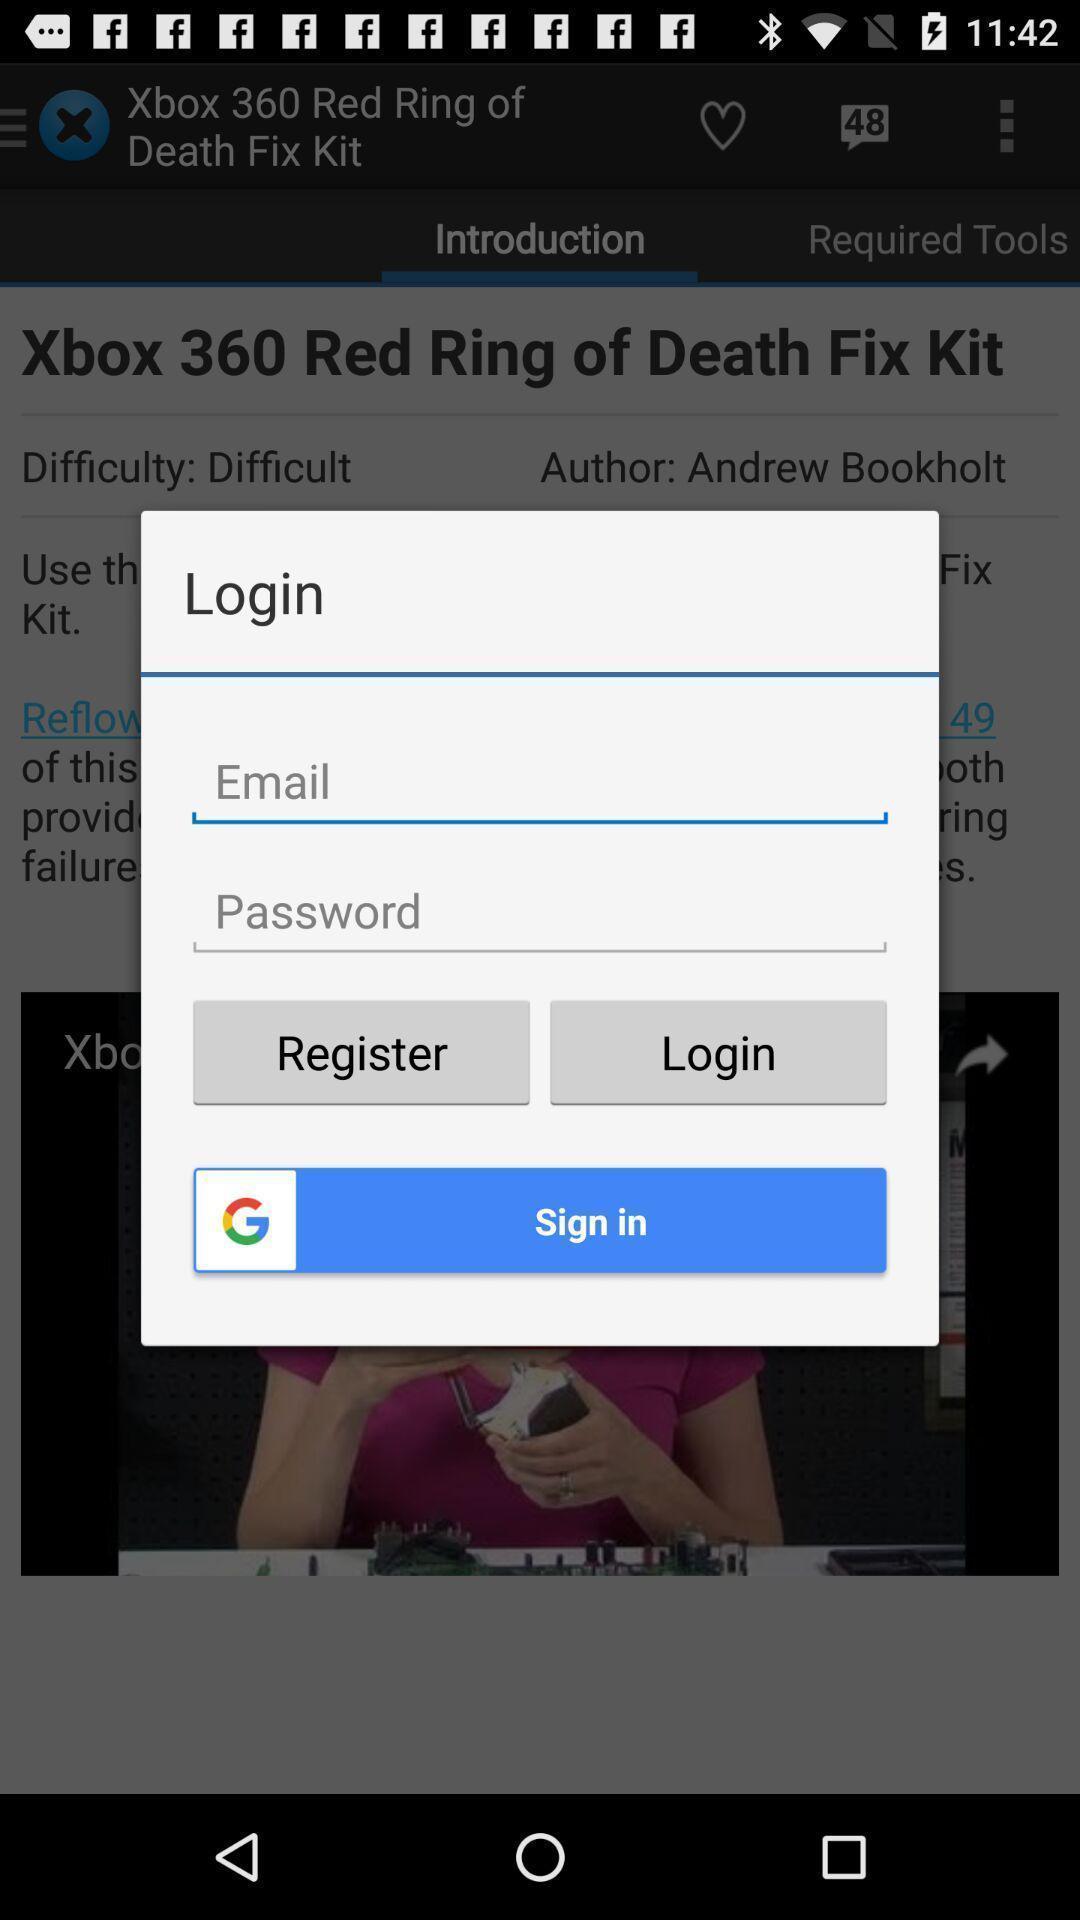Please provide a description for this image. Pop-up window showing login page. 